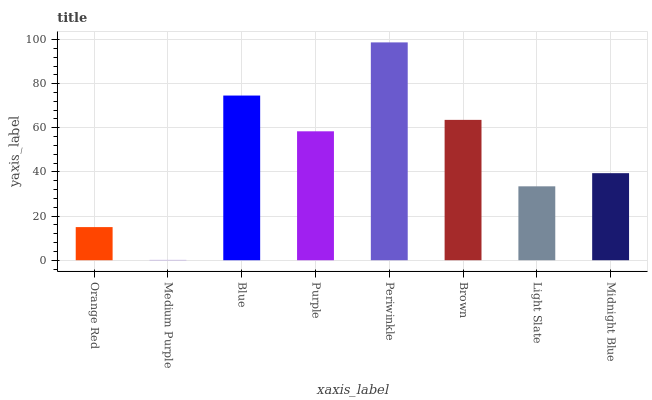Is Medium Purple the minimum?
Answer yes or no. Yes. Is Periwinkle the maximum?
Answer yes or no. Yes. Is Blue the minimum?
Answer yes or no. No. Is Blue the maximum?
Answer yes or no. No. Is Blue greater than Medium Purple?
Answer yes or no. Yes. Is Medium Purple less than Blue?
Answer yes or no. Yes. Is Medium Purple greater than Blue?
Answer yes or no. No. Is Blue less than Medium Purple?
Answer yes or no. No. Is Purple the high median?
Answer yes or no. Yes. Is Midnight Blue the low median?
Answer yes or no. Yes. Is Orange Red the high median?
Answer yes or no. No. Is Purple the low median?
Answer yes or no. No. 